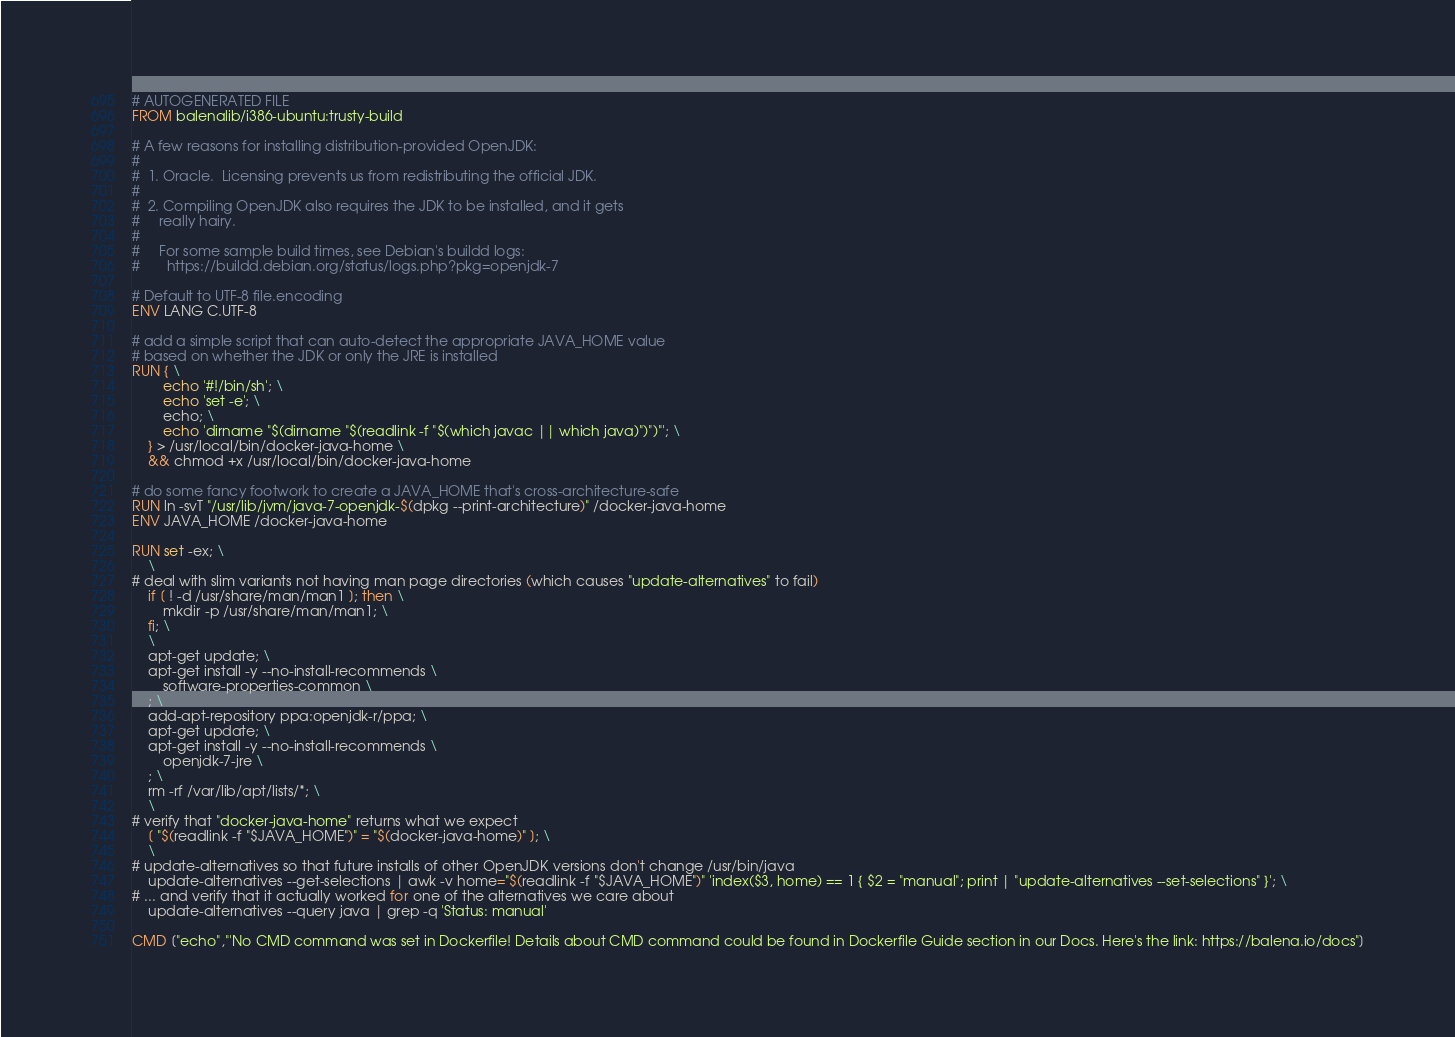Convert code to text. <code><loc_0><loc_0><loc_500><loc_500><_Dockerfile_># AUTOGENERATED FILE
FROM balenalib/i386-ubuntu:trusty-build

# A few reasons for installing distribution-provided OpenJDK:
#
#  1. Oracle.  Licensing prevents us from redistributing the official JDK.
#
#  2. Compiling OpenJDK also requires the JDK to be installed, and it gets
#     really hairy.
#
#     For some sample build times, see Debian's buildd logs:
#       https://buildd.debian.org/status/logs.php?pkg=openjdk-7

# Default to UTF-8 file.encoding
ENV LANG C.UTF-8

# add a simple script that can auto-detect the appropriate JAVA_HOME value
# based on whether the JDK or only the JRE is installed
RUN { \
		echo '#!/bin/sh'; \
		echo 'set -e'; \
		echo; \
		echo 'dirname "$(dirname "$(readlink -f "$(which javac || which java)")")"'; \
	} > /usr/local/bin/docker-java-home \
	&& chmod +x /usr/local/bin/docker-java-home

# do some fancy footwork to create a JAVA_HOME that's cross-architecture-safe
RUN ln -svT "/usr/lib/jvm/java-7-openjdk-$(dpkg --print-architecture)" /docker-java-home
ENV JAVA_HOME /docker-java-home

RUN set -ex; \
	\
# deal with slim variants not having man page directories (which causes "update-alternatives" to fail)
	if [ ! -d /usr/share/man/man1 ]; then \
		mkdir -p /usr/share/man/man1; \
	fi; \
	\
	apt-get update; \
	apt-get install -y --no-install-recommends \
		software-properties-common \
	; \
	add-apt-repository ppa:openjdk-r/ppa; \
	apt-get update; \
	apt-get install -y --no-install-recommends \
		openjdk-7-jre \
	; \
	rm -rf /var/lib/apt/lists/*; \
	\
# verify that "docker-java-home" returns what we expect
	[ "$(readlink -f "$JAVA_HOME")" = "$(docker-java-home)" ]; \
	\
# update-alternatives so that future installs of other OpenJDK versions don't change /usr/bin/java
	update-alternatives --get-selections | awk -v home="$(readlink -f "$JAVA_HOME")" 'index($3, home) == 1 { $2 = "manual"; print | "update-alternatives --set-selections" }'; \
# ... and verify that it actually worked for one of the alternatives we care about
	update-alternatives --query java | grep -q 'Status: manual'

CMD ["echo","'No CMD command was set in Dockerfile! Details about CMD command could be found in Dockerfile Guide section in our Docs. Here's the link: https://balena.io/docs"]</code> 